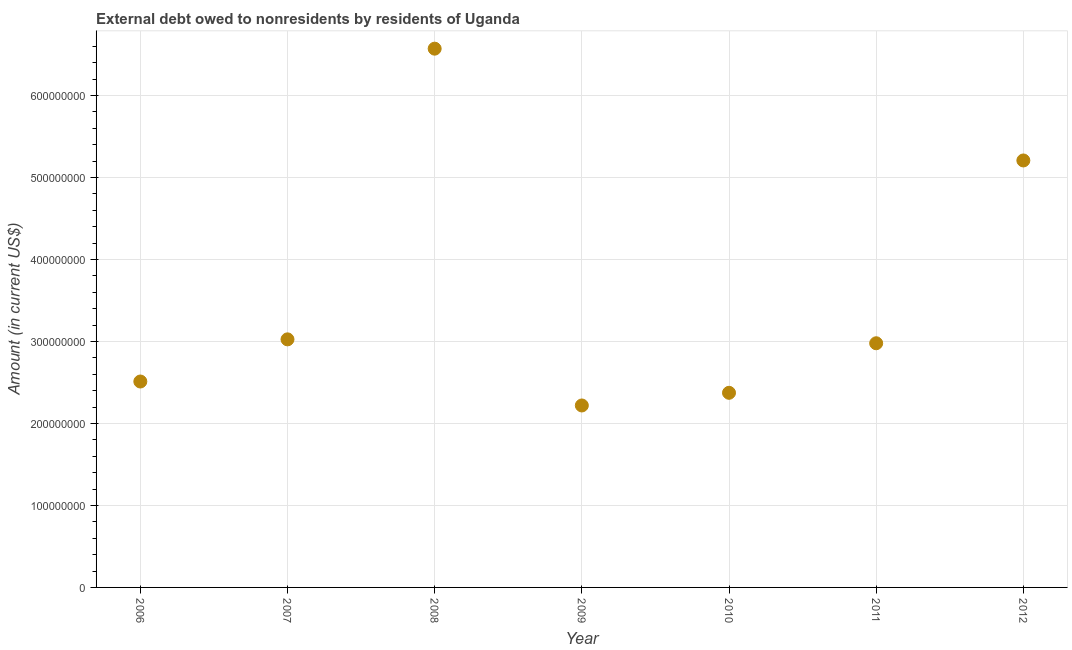What is the debt in 2009?
Keep it short and to the point. 2.22e+08. Across all years, what is the maximum debt?
Offer a very short reply. 6.57e+08. Across all years, what is the minimum debt?
Keep it short and to the point. 2.22e+08. What is the sum of the debt?
Keep it short and to the point. 2.49e+09. What is the difference between the debt in 2006 and 2012?
Offer a terse response. -2.70e+08. What is the average debt per year?
Your answer should be compact. 3.55e+08. What is the median debt?
Your answer should be very brief. 2.98e+08. In how many years, is the debt greater than 580000000 US$?
Your response must be concise. 1. Do a majority of the years between 2009 and 2007 (inclusive) have debt greater than 40000000 US$?
Ensure brevity in your answer.  No. What is the ratio of the debt in 2009 to that in 2010?
Ensure brevity in your answer.  0.93. Is the debt in 2006 less than that in 2008?
Make the answer very short. Yes. Is the difference between the debt in 2007 and 2011 greater than the difference between any two years?
Give a very brief answer. No. What is the difference between the highest and the second highest debt?
Your answer should be compact. 1.36e+08. Is the sum of the debt in 2008 and 2011 greater than the maximum debt across all years?
Provide a succinct answer. Yes. What is the difference between the highest and the lowest debt?
Give a very brief answer. 4.35e+08. Does the debt monotonically increase over the years?
Your answer should be compact. No. How many years are there in the graph?
Provide a succinct answer. 7. What is the difference between two consecutive major ticks on the Y-axis?
Provide a succinct answer. 1.00e+08. Does the graph contain any zero values?
Ensure brevity in your answer.  No. What is the title of the graph?
Your answer should be compact. External debt owed to nonresidents by residents of Uganda. What is the label or title of the X-axis?
Your answer should be compact. Year. What is the Amount (in current US$) in 2006?
Ensure brevity in your answer.  2.51e+08. What is the Amount (in current US$) in 2007?
Keep it short and to the point. 3.03e+08. What is the Amount (in current US$) in 2008?
Your response must be concise. 6.57e+08. What is the Amount (in current US$) in 2009?
Your answer should be compact. 2.22e+08. What is the Amount (in current US$) in 2010?
Your answer should be compact. 2.37e+08. What is the Amount (in current US$) in 2011?
Ensure brevity in your answer.  2.98e+08. What is the Amount (in current US$) in 2012?
Your answer should be compact. 5.21e+08. What is the difference between the Amount (in current US$) in 2006 and 2007?
Ensure brevity in your answer.  -5.14e+07. What is the difference between the Amount (in current US$) in 2006 and 2008?
Provide a succinct answer. -4.06e+08. What is the difference between the Amount (in current US$) in 2006 and 2009?
Give a very brief answer. 2.92e+07. What is the difference between the Amount (in current US$) in 2006 and 2010?
Your answer should be very brief. 1.38e+07. What is the difference between the Amount (in current US$) in 2006 and 2011?
Ensure brevity in your answer.  -4.67e+07. What is the difference between the Amount (in current US$) in 2006 and 2012?
Offer a very short reply. -2.70e+08. What is the difference between the Amount (in current US$) in 2007 and 2008?
Give a very brief answer. -3.55e+08. What is the difference between the Amount (in current US$) in 2007 and 2009?
Keep it short and to the point. 8.06e+07. What is the difference between the Amount (in current US$) in 2007 and 2010?
Provide a short and direct response. 6.52e+07. What is the difference between the Amount (in current US$) in 2007 and 2011?
Keep it short and to the point. 4.76e+06. What is the difference between the Amount (in current US$) in 2007 and 2012?
Offer a very short reply. -2.18e+08. What is the difference between the Amount (in current US$) in 2008 and 2009?
Your answer should be compact. 4.35e+08. What is the difference between the Amount (in current US$) in 2008 and 2010?
Your answer should be very brief. 4.20e+08. What is the difference between the Amount (in current US$) in 2008 and 2011?
Ensure brevity in your answer.  3.59e+08. What is the difference between the Amount (in current US$) in 2008 and 2012?
Your response must be concise. 1.36e+08. What is the difference between the Amount (in current US$) in 2009 and 2010?
Your answer should be very brief. -1.54e+07. What is the difference between the Amount (in current US$) in 2009 and 2011?
Your answer should be very brief. -7.59e+07. What is the difference between the Amount (in current US$) in 2009 and 2012?
Your answer should be very brief. -2.99e+08. What is the difference between the Amount (in current US$) in 2010 and 2011?
Provide a short and direct response. -6.04e+07. What is the difference between the Amount (in current US$) in 2010 and 2012?
Your answer should be compact. -2.83e+08. What is the difference between the Amount (in current US$) in 2011 and 2012?
Provide a short and direct response. -2.23e+08. What is the ratio of the Amount (in current US$) in 2006 to that in 2007?
Your answer should be compact. 0.83. What is the ratio of the Amount (in current US$) in 2006 to that in 2008?
Make the answer very short. 0.38. What is the ratio of the Amount (in current US$) in 2006 to that in 2009?
Give a very brief answer. 1.13. What is the ratio of the Amount (in current US$) in 2006 to that in 2010?
Keep it short and to the point. 1.06. What is the ratio of the Amount (in current US$) in 2006 to that in 2011?
Your response must be concise. 0.84. What is the ratio of the Amount (in current US$) in 2006 to that in 2012?
Keep it short and to the point. 0.48. What is the ratio of the Amount (in current US$) in 2007 to that in 2008?
Keep it short and to the point. 0.46. What is the ratio of the Amount (in current US$) in 2007 to that in 2009?
Provide a succinct answer. 1.36. What is the ratio of the Amount (in current US$) in 2007 to that in 2010?
Give a very brief answer. 1.27. What is the ratio of the Amount (in current US$) in 2007 to that in 2011?
Give a very brief answer. 1.02. What is the ratio of the Amount (in current US$) in 2007 to that in 2012?
Your response must be concise. 0.58. What is the ratio of the Amount (in current US$) in 2008 to that in 2009?
Give a very brief answer. 2.96. What is the ratio of the Amount (in current US$) in 2008 to that in 2010?
Your answer should be very brief. 2.77. What is the ratio of the Amount (in current US$) in 2008 to that in 2011?
Provide a succinct answer. 2.21. What is the ratio of the Amount (in current US$) in 2008 to that in 2012?
Your response must be concise. 1.26. What is the ratio of the Amount (in current US$) in 2009 to that in 2010?
Your response must be concise. 0.94. What is the ratio of the Amount (in current US$) in 2009 to that in 2011?
Offer a terse response. 0.74. What is the ratio of the Amount (in current US$) in 2009 to that in 2012?
Provide a succinct answer. 0.43. What is the ratio of the Amount (in current US$) in 2010 to that in 2011?
Your answer should be very brief. 0.8. What is the ratio of the Amount (in current US$) in 2010 to that in 2012?
Your answer should be compact. 0.46. What is the ratio of the Amount (in current US$) in 2011 to that in 2012?
Make the answer very short. 0.57. 